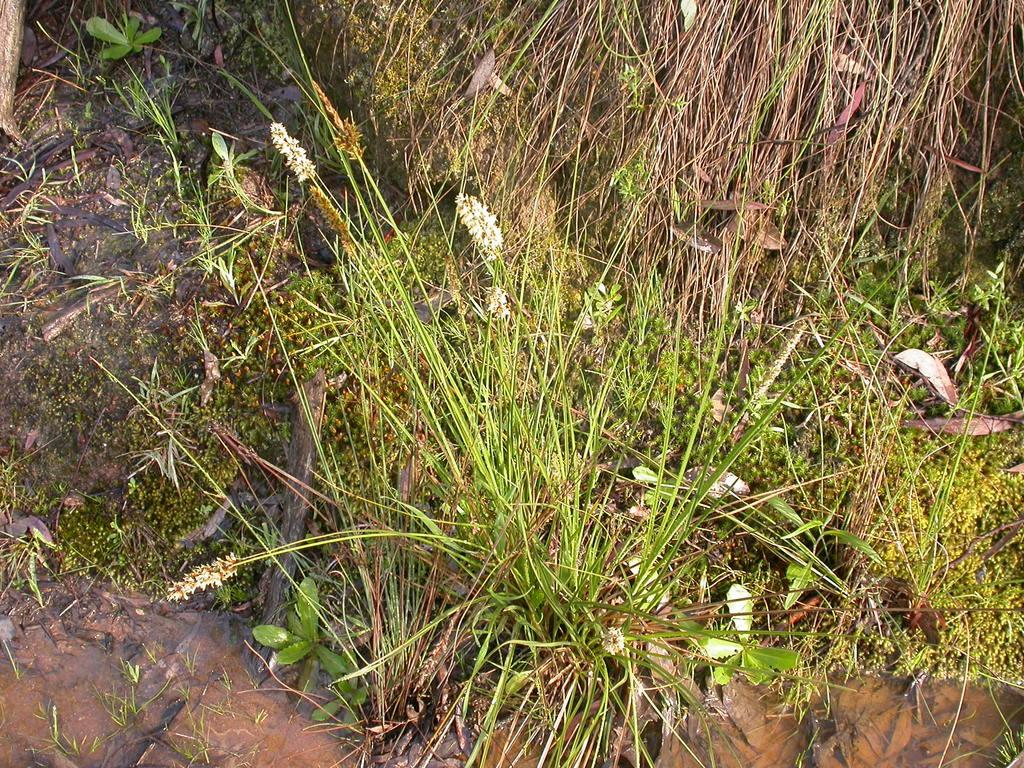What type of vegetation is present on the ground in the image? There is green grass on the ground in the image. What type of string can be seen causing disgust in the image? There is no string present in the image, and no indication of disgust. 